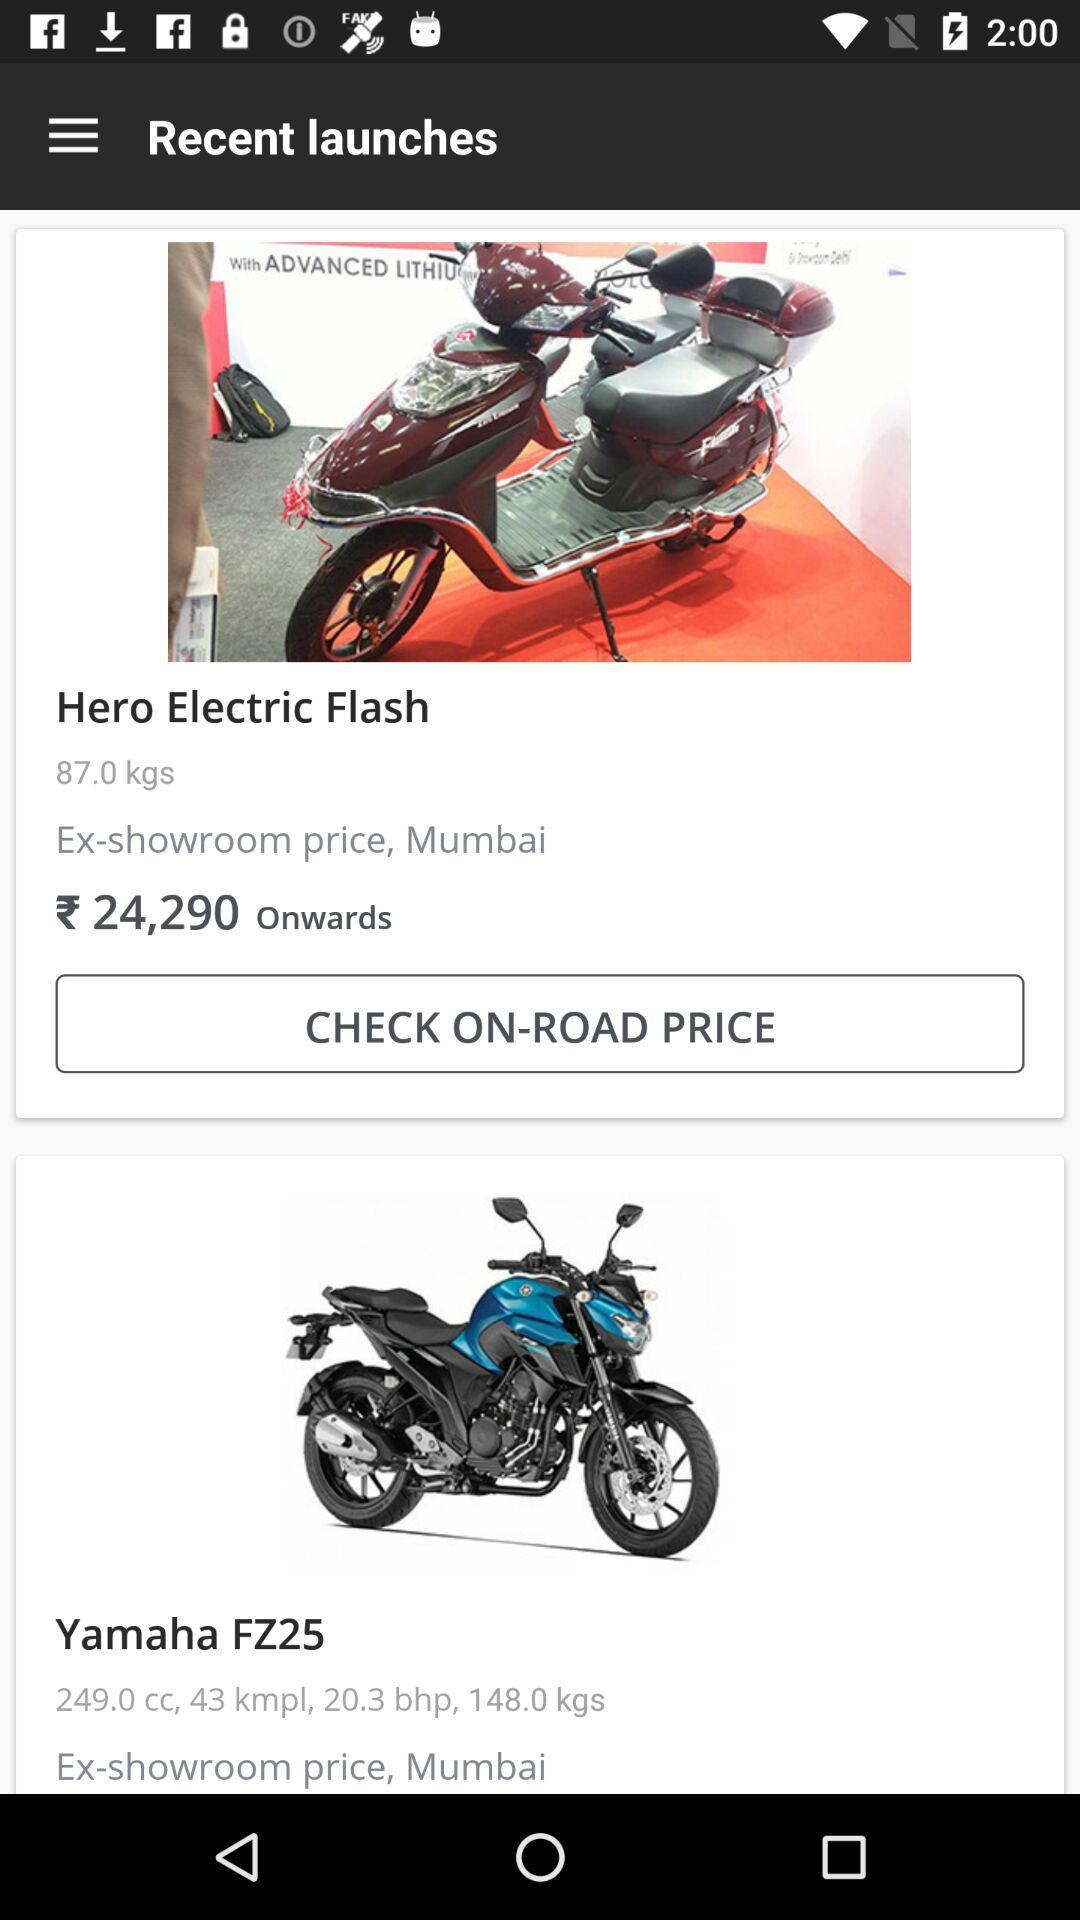What is the price of "Hero Electric Flash"? The price of "Hero Electric Flash" is ₹24,290 onwards. 